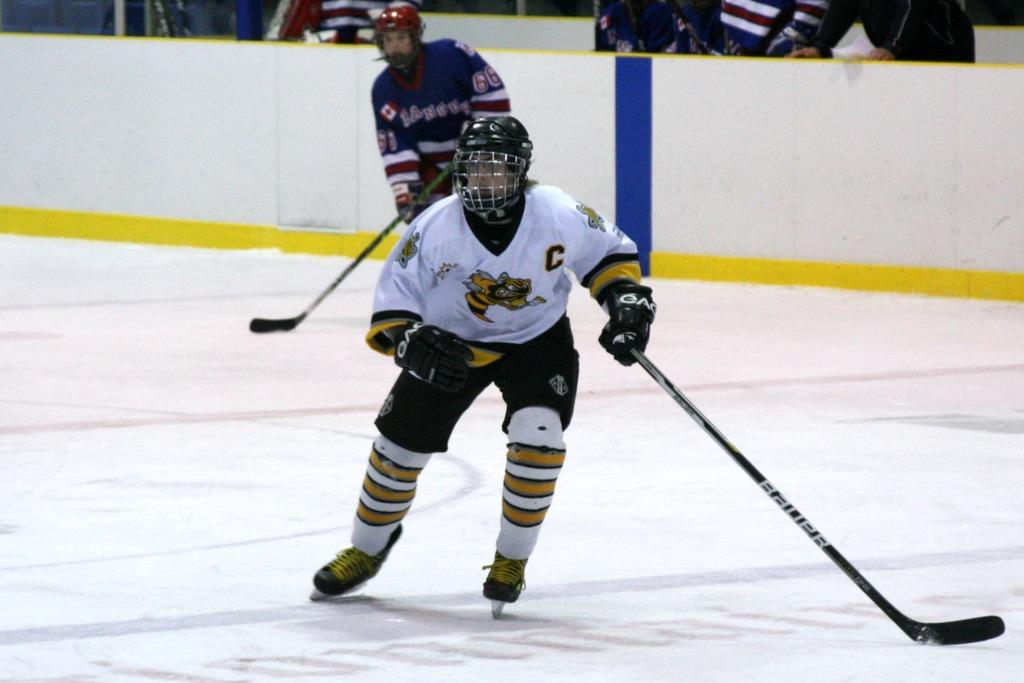How many people are in the image? There are two people in the image. What are the people holding in the image? The two people are holding hockey sticks. What protective gear are the people wearing? The people are wearing helmets and gloves. What can be seen in the background of the image? There is a wall and people visible in the background of the image. What type of ink can be seen on the hockey sticks in the image? There is no ink visible on the hockey sticks in the image. Can you tell me how many times the people touch the glass in the image? There is no glass present in the image for the people to touch. 